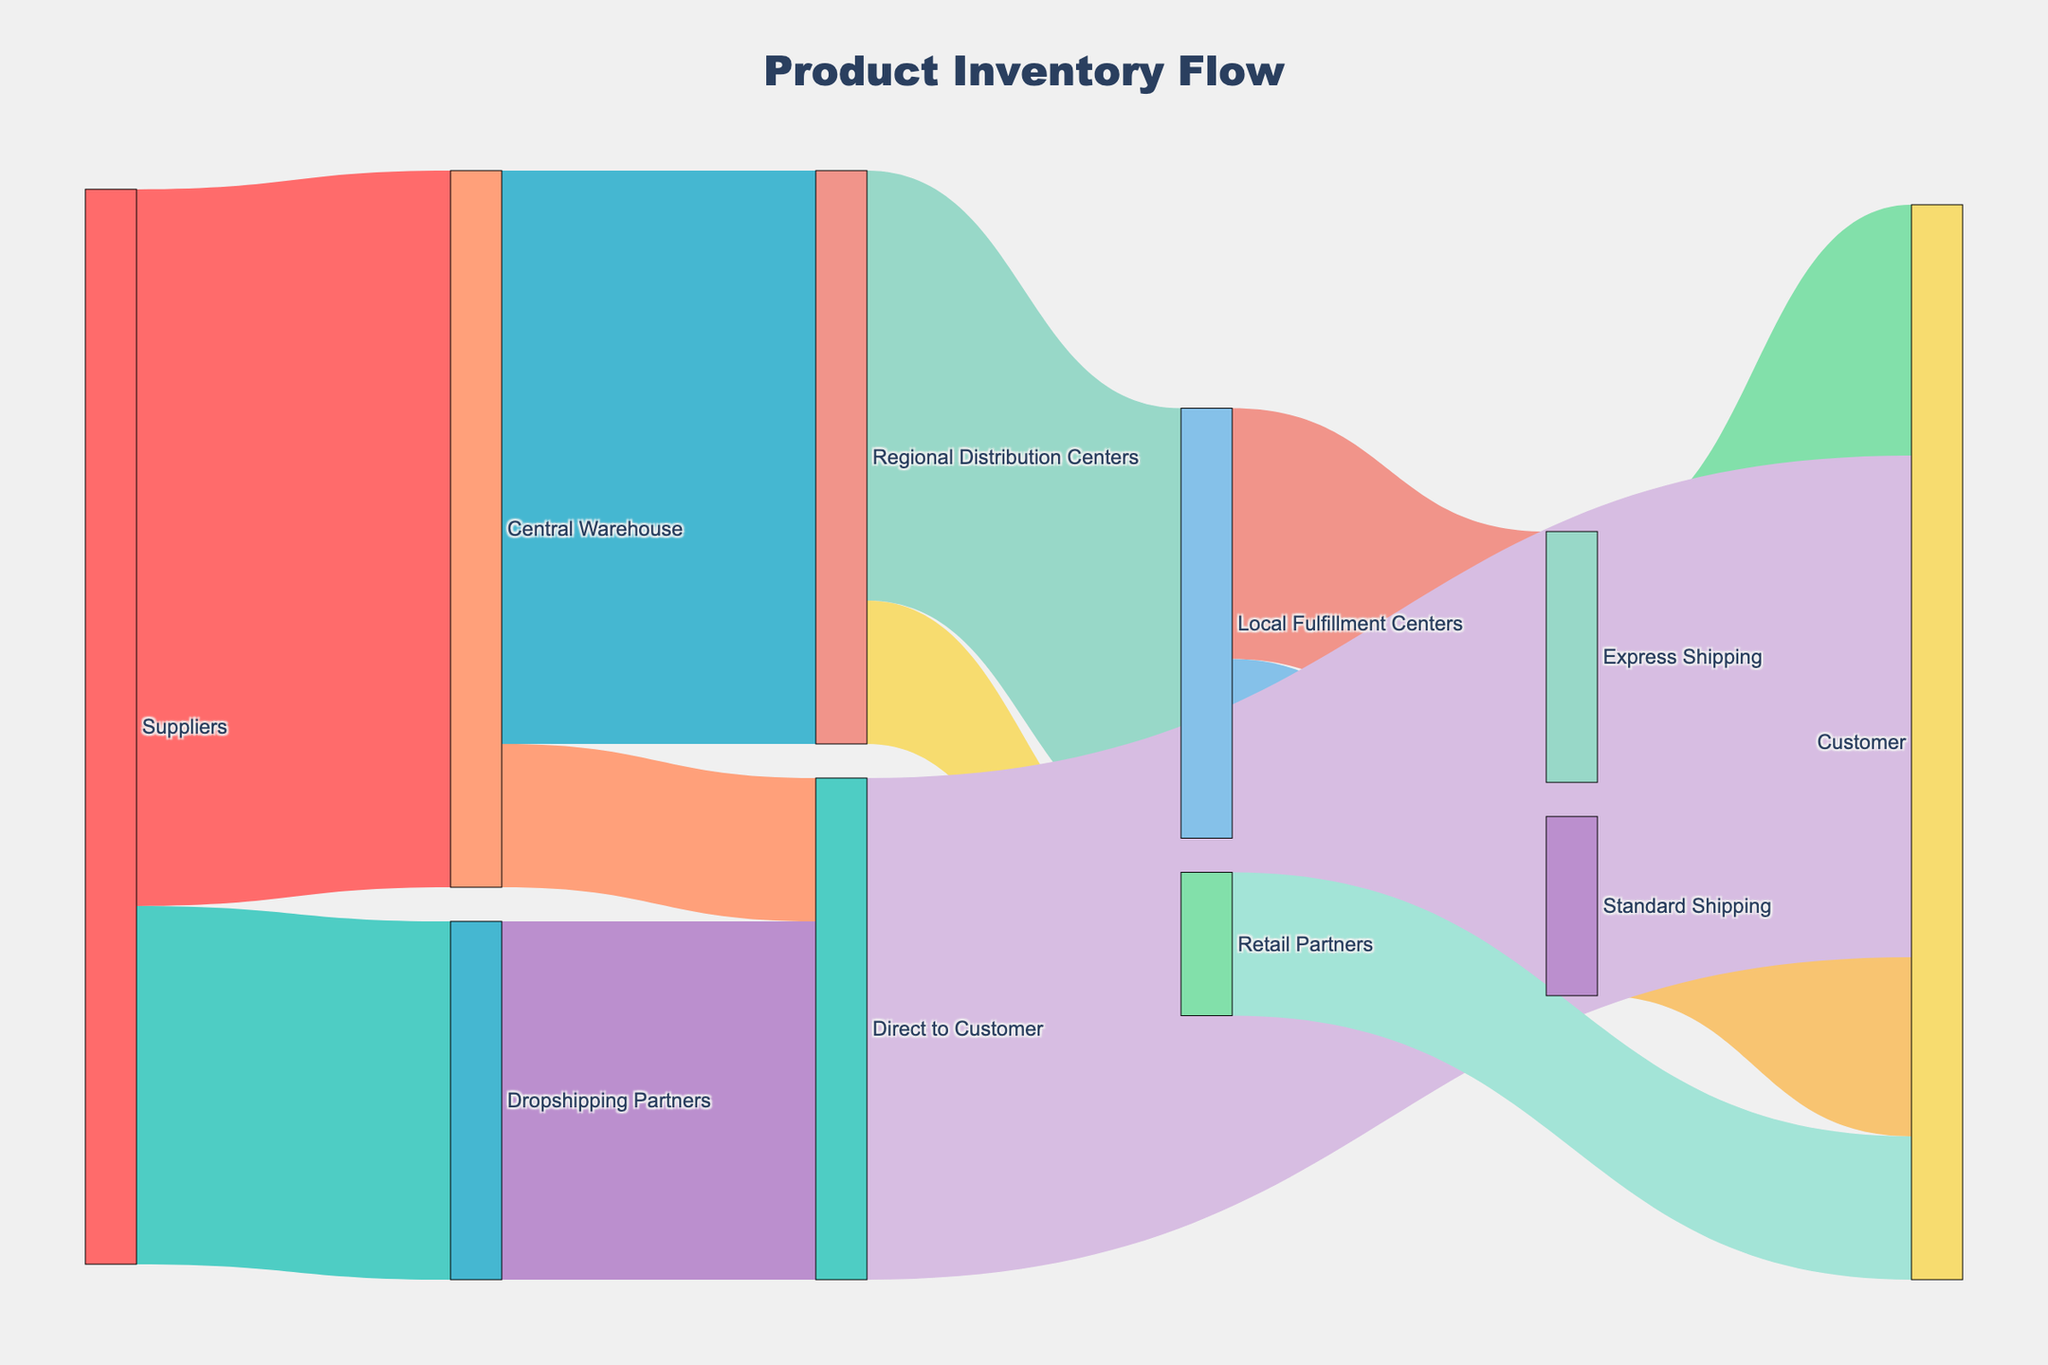What is the title of the figure? The title of the figure can be found at the top of the diagram.
Answer: Product Inventory Flow How many sources are there in total? To find the total number of sources, count the unique names in the source column of the figure.
Answer: 5 Which node has the highest flow of products to customers directly? Observe the connections leading directly to the "Customer" node and identify the node with the largest value. The nodes are "Direct to Customer" with 7000, "Express Shipping" with 3500, "Standard Shipping" with 2500, and "Retail Partners" with 2000. The highest is "Direct to Customer".
Answer: Direct to Customer What's the total value flowing out from the Central Warehouse? Identify all flows originating from the Central Warehouse, which are "Central Warehouse to Regional Distribution Centers" (8000) and "Central Warehouse to Direct to Customer" (2000). Sum these values. 8000 + 2000 = 10000
Answer: 10000 Compare the flows from the Central Warehouse to the Regional Distribution Centers and directly to customers. Which is higher and by how much? The flow to Regional Distribution Centers is 8000 and directly to customers is 2000. The difference is 8000 - 2000 = 6000, and flow to Regional Distribution Centers is higher.
Answer: Regional Distribution Centers by 6000 What percentage of the products supplied to the Central Warehouse comes from Suppliers? The total incoming flow to the Central Warehouse is exclusively from Suppliers, which is 10000. Since this is the sole input, it represents 100%.
Answer: 100% Calculate the total number of products reaching customers from all nodes. Is it consistent with the figure? Sum all the values leading to the "Customer" node: 7000 (Direct to Customer) + 3500 (Express Shipping) + 2500 (Standard Shipping) + 2000 (Retail Partners) = 15000. Compare this with the total outgoing value from the sources (10000 + 5000), which also equals 15000, indicating consistency.
Answer: 15000, Yes Which shipping option delivers more products to customers, Express Shipping or Standard Shipping? Compare the final flow values to the customer: Express Shipping with 3500 and Standard Shipping with 2500.
Answer: Express Shipping If you wanted to decrease dependency on Dropshipping Partners, which alternative pathways could compensate for the 5000 products they fulfill? Examine other pathways where additional flow of 5000 can be redistributed: Central Warehouse to Direct to Customer (2000) could potentially increase, and more products can be routed through Regional Distribution Centers to Local Fulfillment Centers or Retail Partners to indirectly deliver to customers.
Answer: Regional Distribution Centers and Direct from Central Warehouse 